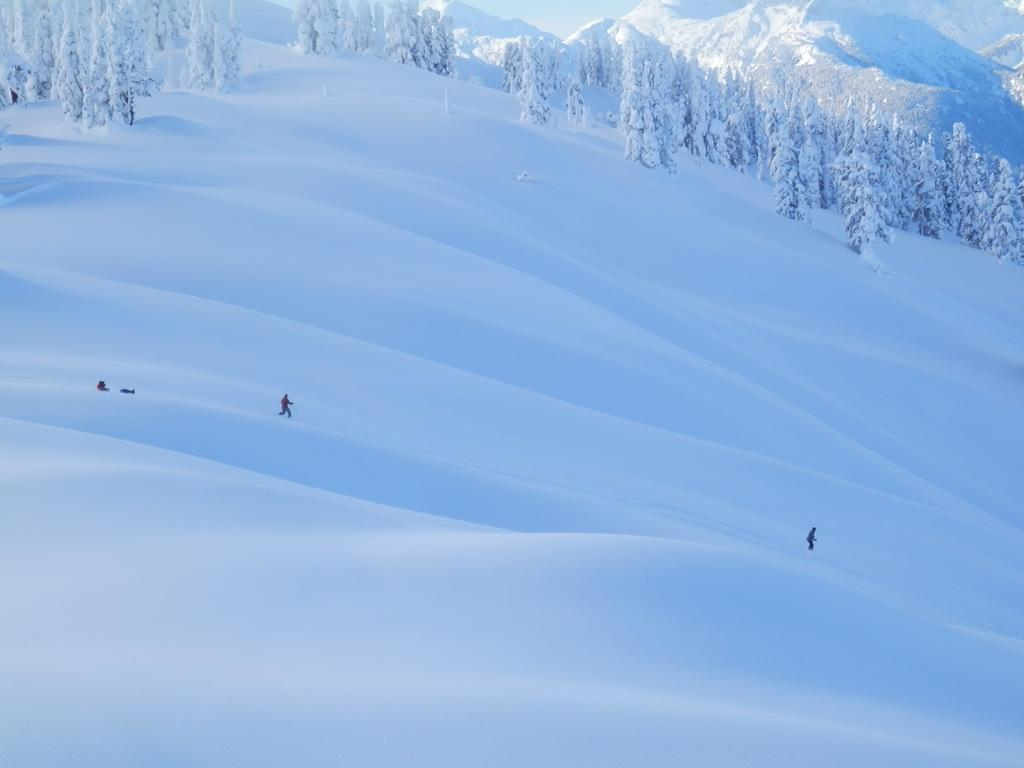Who or what can be seen in the image? There are people in the image. What are the people doing in the image? The people are skating. On what surface are the people skating? The skating is taking place on snow. What can be seen in the distance in the image? There are trees and mountains in the background of the image. How many geese are flying over the mountains in the image? There are no geese visible in the image; it features people skating on snow with trees and mountains in the background. What is the purpose of the branch in the image? There is no branch present in the image. 